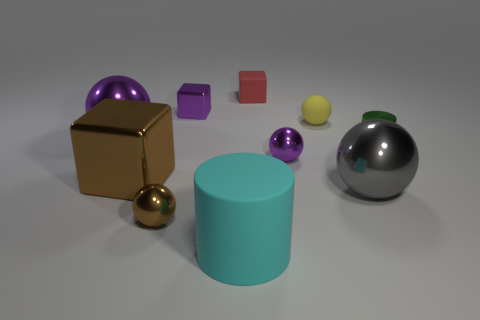Subtract all gray balls. How many balls are left? 4 Subtract all small rubber spheres. How many spheres are left? 4 Subtract all brown balls. Subtract all brown cubes. How many balls are left? 4 Subtract all cylinders. How many objects are left? 8 Add 7 large gray metal balls. How many large gray metal balls are left? 8 Add 6 tiny metal balls. How many tiny metal balls exist? 8 Subtract 0 blue cubes. How many objects are left? 10 Subtract all blue shiny things. Subtract all purple cubes. How many objects are left? 9 